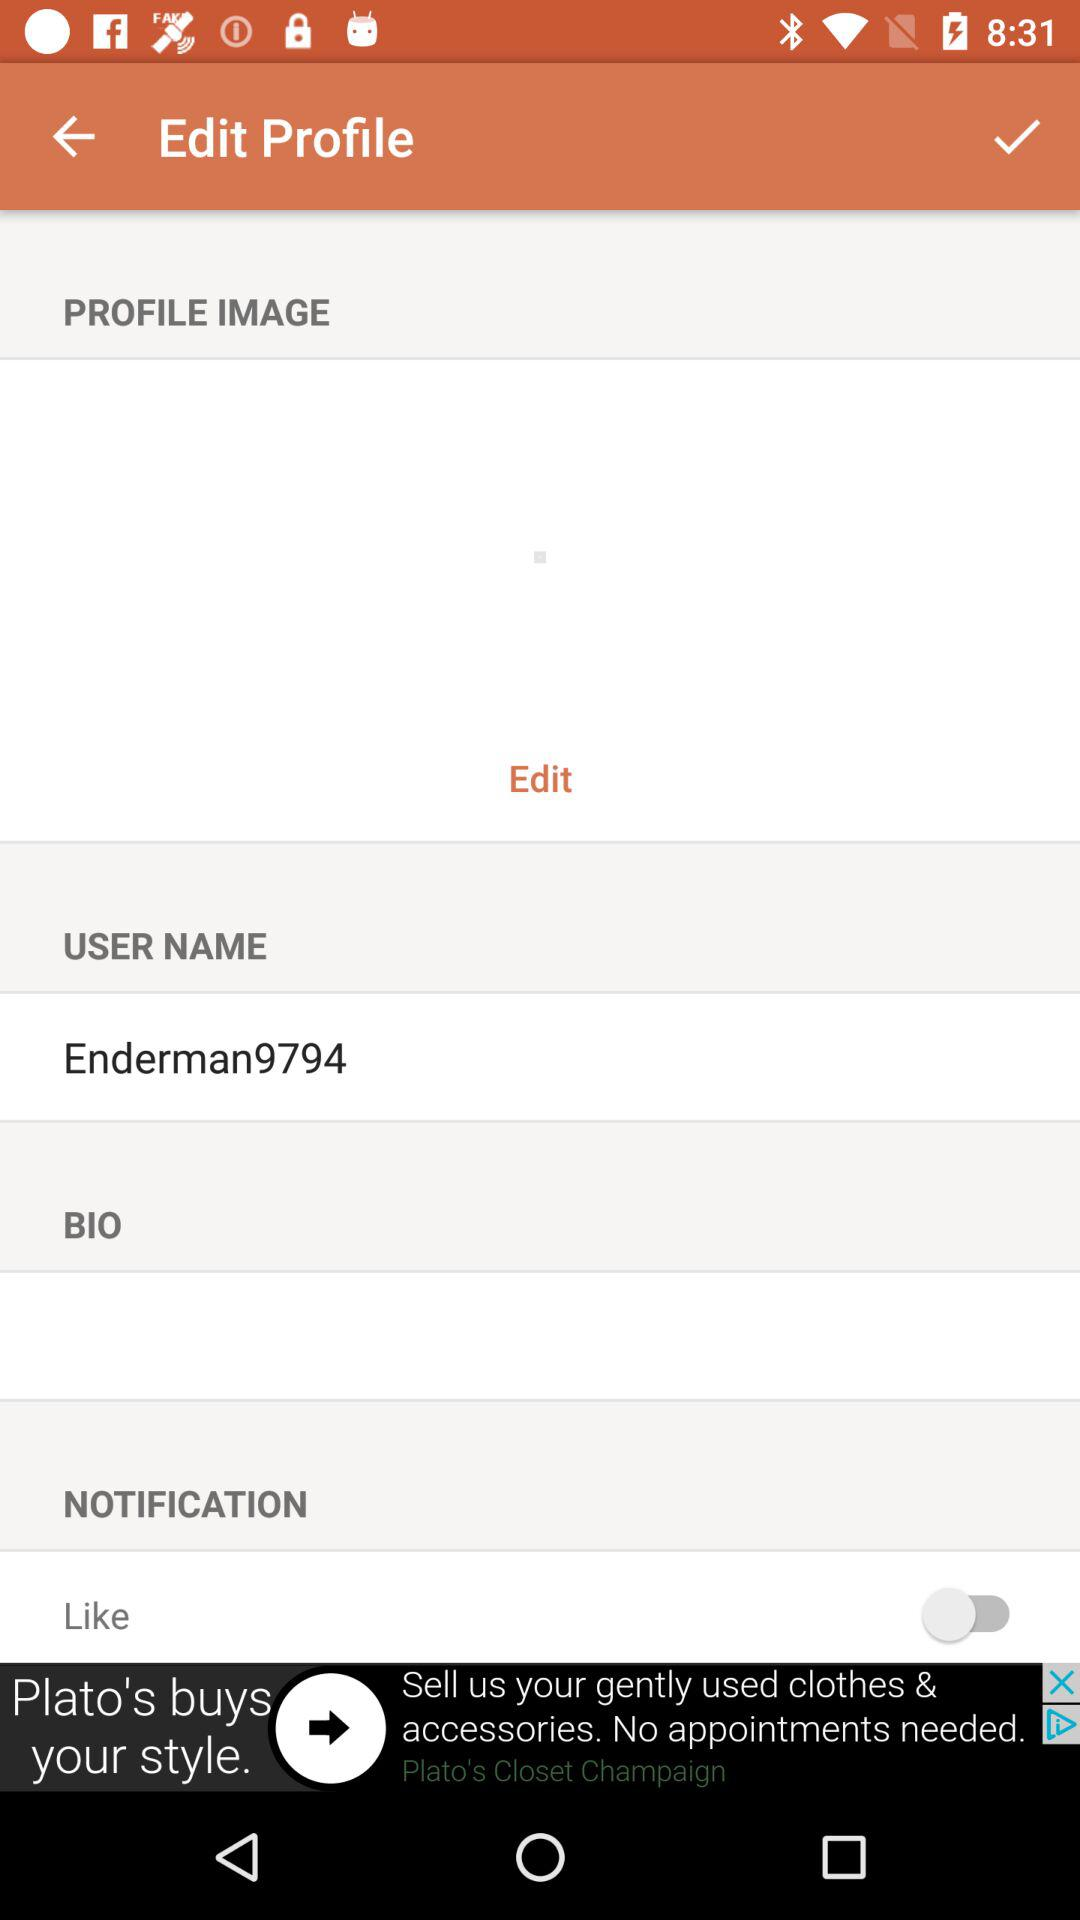What is the name of the user? The user name is "Enderman9794". 